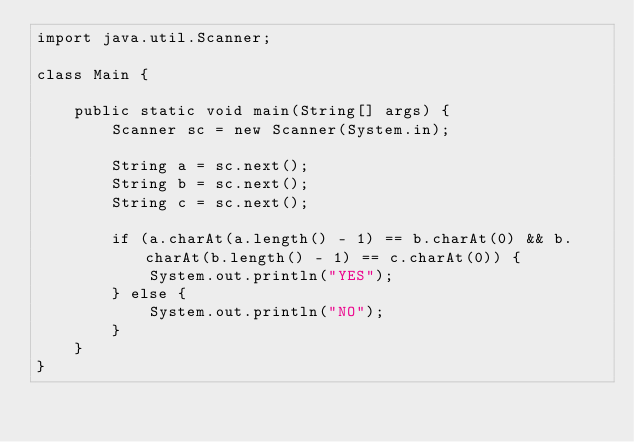<code> <loc_0><loc_0><loc_500><loc_500><_Java_>import java.util.Scanner;

class Main {

    public static void main(String[] args) {
        Scanner sc = new Scanner(System.in);

        String a = sc.next();
        String b = sc.next();
        String c = sc.next();

        if (a.charAt(a.length() - 1) == b.charAt(0) && b.charAt(b.length() - 1) == c.charAt(0)) {
            System.out.println("YES");
        } else {
            System.out.println("NO");
        }
    }
}</code> 